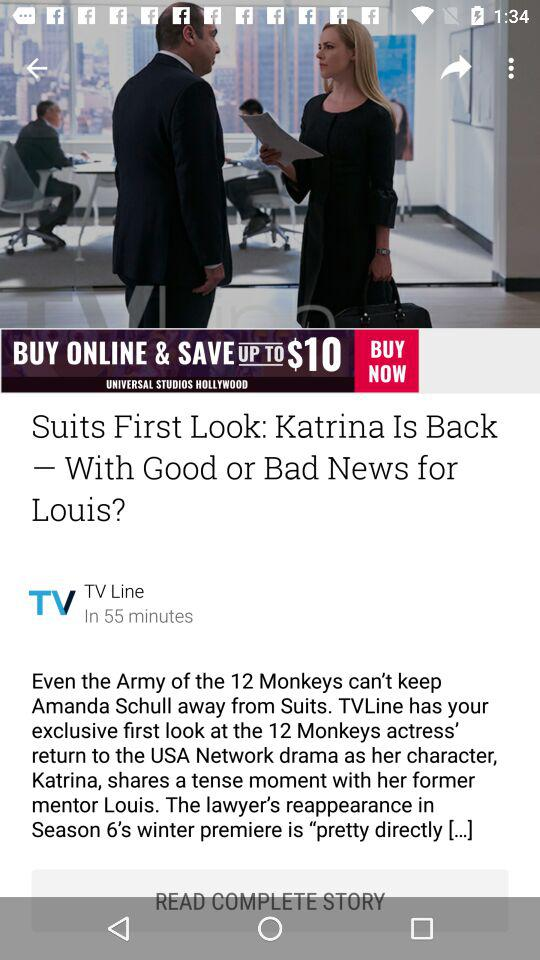How many episodes are left? There are 60 episodes left. 